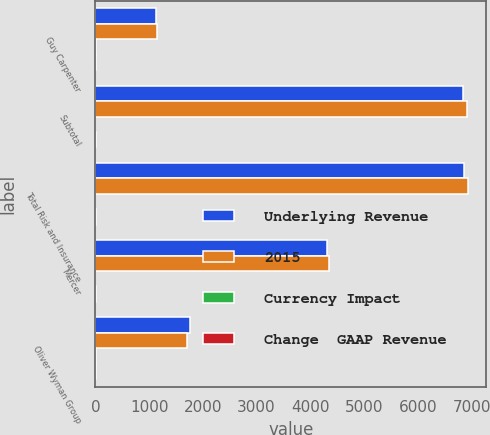Convert chart to OTSL. <chart><loc_0><loc_0><loc_500><loc_500><stacked_bar_chart><ecel><fcel>Guy Carpenter<fcel>Subtotal<fcel>Total Risk and Insurance<fcel>Mercer<fcel>Oliver Wyman Group<nl><fcel>Underlying Revenue<fcel>1121<fcel>6848<fcel>6869<fcel>4313<fcel>1751<nl><fcel>2015<fcel>1154<fcel>6907<fcel>6931<fcel>4350<fcel>1709<nl><fcel>Currency Impact<fcel>3<fcel>1<fcel>1<fcel>1<fcel>3<nl><fcel>Change  GAAP Revenue<fcel>4<fcel>6<fcel>6<fcel>7<fcel>6<nl></chart> 